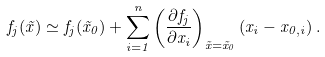Convert formula to latex. <formula><loc_0><loc_0><loc_500><loc_500>f _ { j } ( { \vec { x } } ) \simeq f _ { j } ( { \vec { x } } _ { 0 } ) + \sum _ { i = 1 } ^ { n } \left ( \frac { \partial f _ { j } } { \partial x _ { i } } \right ) _ { { \vec { x } } = { \vec { x } } _ { 0 } } ( x _ { i } - x _ { 0 , i } ) \, .</formula> 